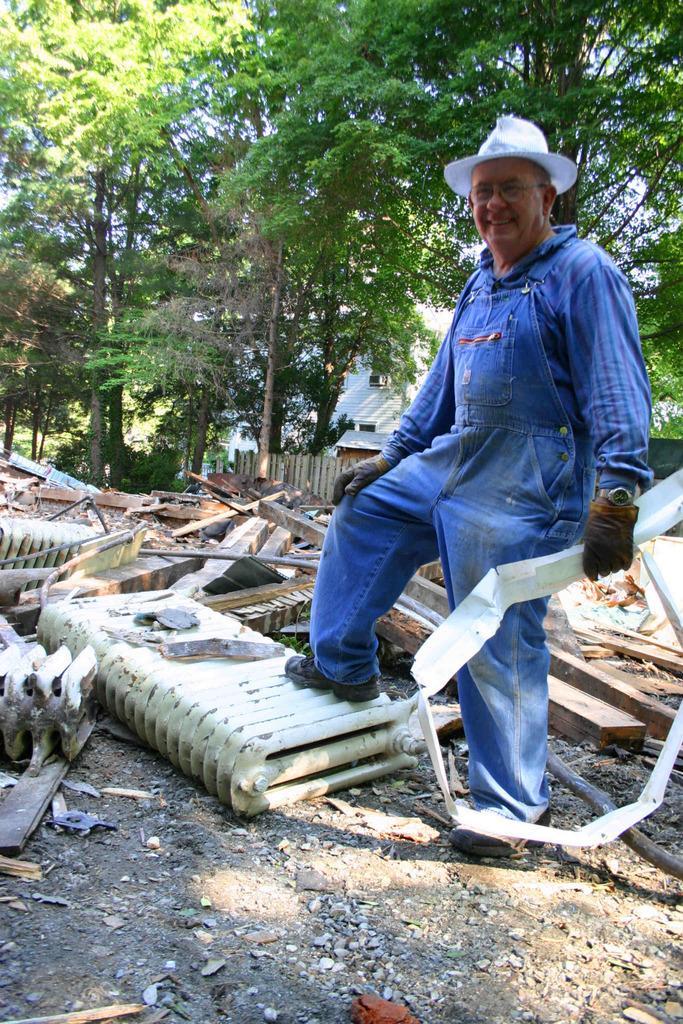How would you summarize this image in a sentence or two? This picture is taken from the outside of the city. In this image, on the right side, we can see a man wearing a blue color dress is standing and holding an object in his hand. In this image, in the middle, we can see a metal object. In the background, we can see some wood objects, plants, trees, wood wall, house. At the top, we can see a sky, at the bottom, we can see some metal objects, wood objects and a land with some stones. 